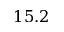<formula> <loc_0><loc_0><loc_500><loc_500>1 5 . 2</formula> 